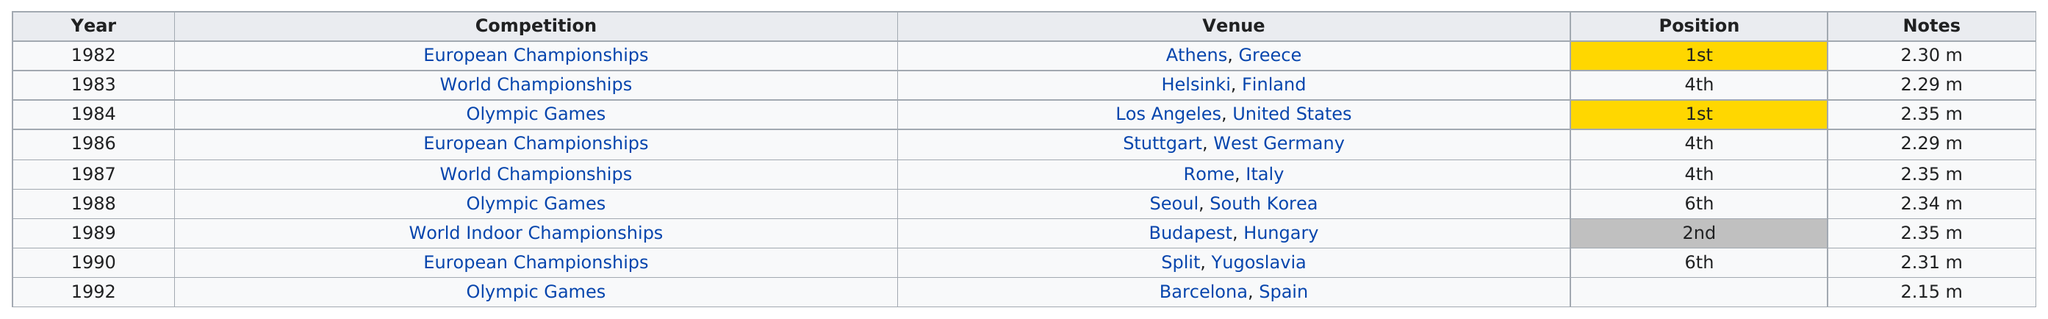Point out several critical features in this image. The first Olympic Games were held in Los Angeles, United States in 1984. The position held the most number of times is the 4th position. Both the 1990 European Championships and the 1988 Olympic Games saw this competitor finish in the position of 6th. This competitor placed 5th or better in 6 games out of how many games they played in total? The total amount of competitions that the person participated in is 9. 